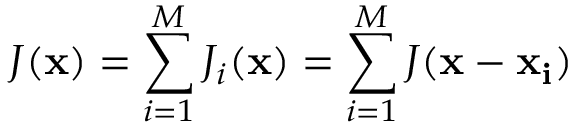Convert formula to latex. <formula><loc_0><loc_0><loc_500><loc_500>J ( { x } ) = \sum _ { i = 1 } ^ { M } J _ { i } ( { x } ) = \sum _ { i = 1 } ^ { M } J ( { x } - { x _ { i } } )</formula> 